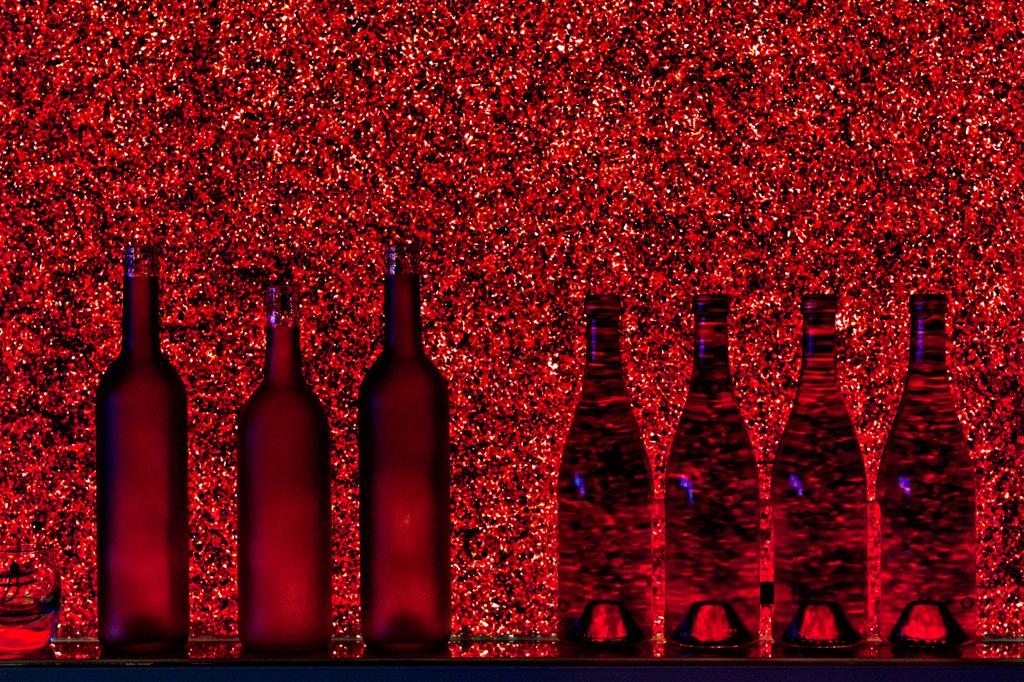How many bottles are visible in the image? There are 7 bottles in the image. Where are the bottles located in relation to the image? The bottles are in the foreground of the image. What color is the background of the image? The background of the image is red in color. What type of fruit is sitting on the button in the image? There is no fruit or button present in the image. How does the image end, considering the background color? The image does not have an ending, as it is a still image. 